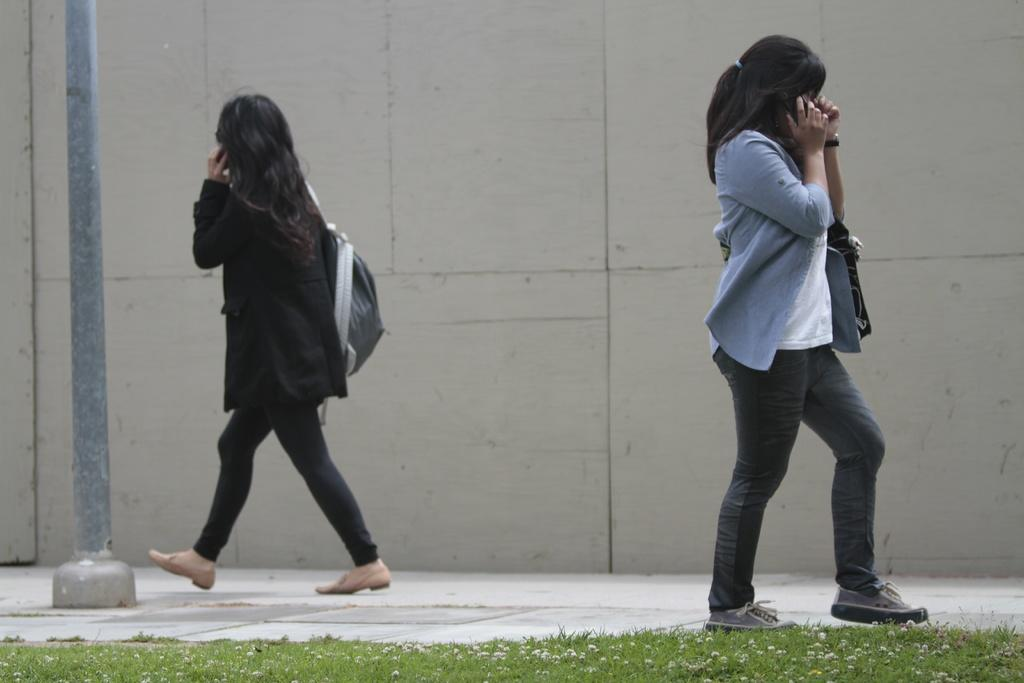How many women are walking in the image? There are two women walking in the image, one on the right side and one on the left side. What is located on the left side of the image? There is a pole on the left side of the image. What type of vegetation is at the bottom of the image? There is grass at the bottom of the image. What can be seen in the background of the image? There is a wall in the background of the image. What type of root can be seen growing on the wall in the image? There is no root growing on the wall in the image; only a woman walking on the left side and a pole are present on that side. 